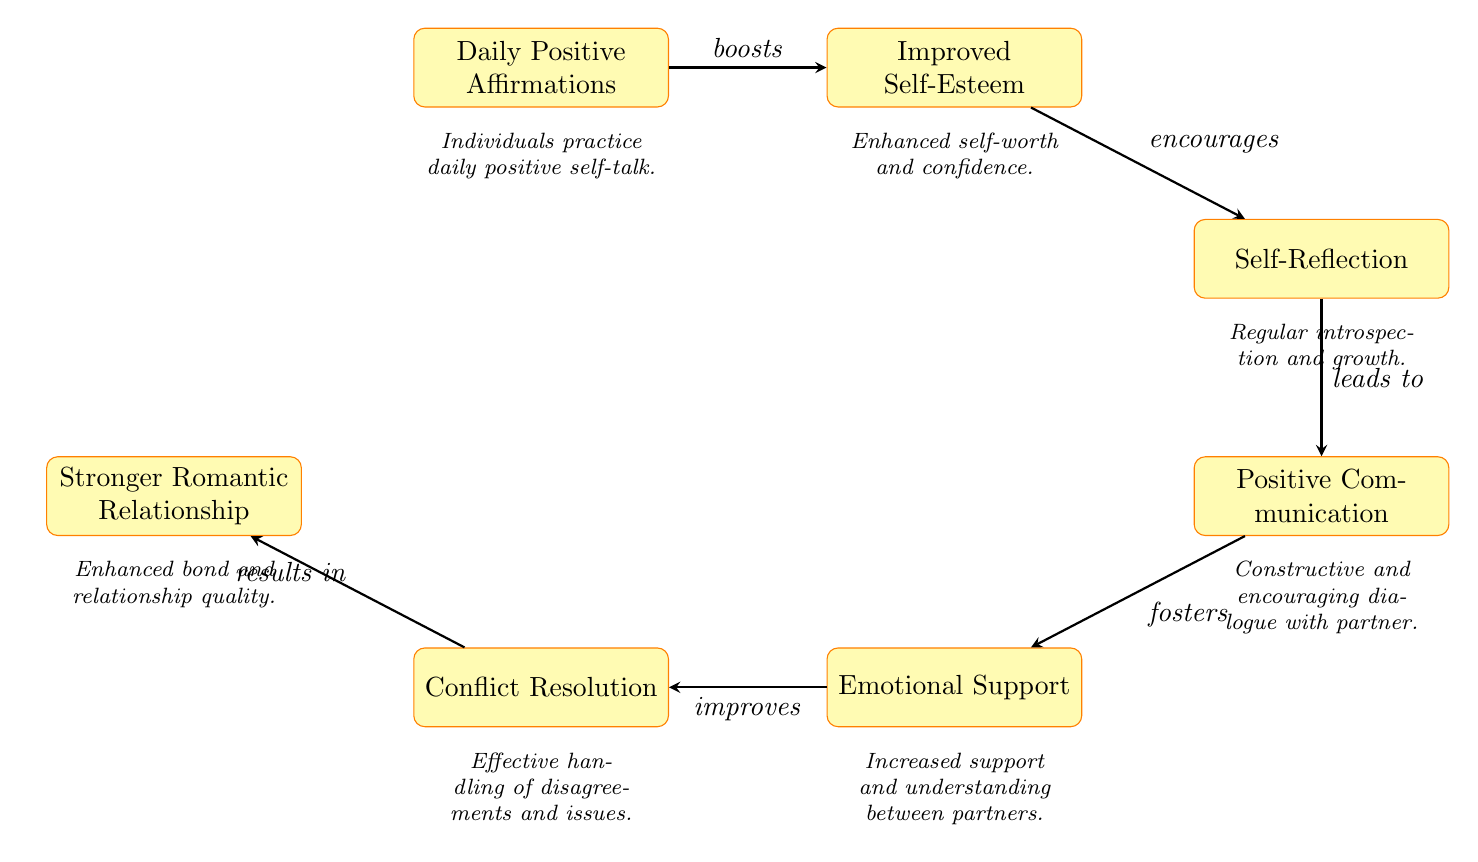What is the first node in the diagram? The first node in the diagram is "Daily Positive Affirmations," which starts the flow of information.
Answer: Daily Positive Affirmations How many nodes are in the diagram? The diagram contains six nodes that represent different concepts connected by arrows showing the flow of influence.
Answer: 6 What does improved self-esteem encourage? Improved self-esteem encourages "Self-Reflection," as indicated by the arrow pointing from "Improved Self-Esteem" to "Self-Reflection."
Answer: Self-Reflection What is the last node in the diagram? The last node in the diagram is "Stronger Romantic Relationship," which indicates the final outcome of the process represented in the flowchart.
Answer: Stronger Romantic Relationship Which node is connected to both "Positive Communication" and "Conflict Resolution"? The node connected to both "Positive Communication" and "Conflict Resolution" is "Emotional Support," serving as a crucial intermediary in the flow.
Answer: Emotional Support What does positive communication lead to? Positive communication leads to "Emotional Support," as depicted by the arrow connecting these two nodes in the diagram.
Answer: Emotional Support What is the primary effect of daily positive affirmations? The primary effect of daily positive affirmations is to boost self-esteem, as shown by the arrow leading from "Daily Positive Affirmations" to "Improved Self-Esteem."
Answer: Improves Self-Esteem How does conflict resolution relate to the overall improvement in relationships? Conflict resolution improves relationships by ultimately resulting in a "Stronger Romantic Relationship," as highlighted by the arrow leading from "Conflict Resolution" to this final node.
Answer: Stronger Romantic Relationship What does self-reflection result in? Self-reflection results in "Positive Communication," as indicated by the direct flow from the self-reflection node to the communication node, showing how introspection aids in better dialogue.
Answer: Positive Communication 